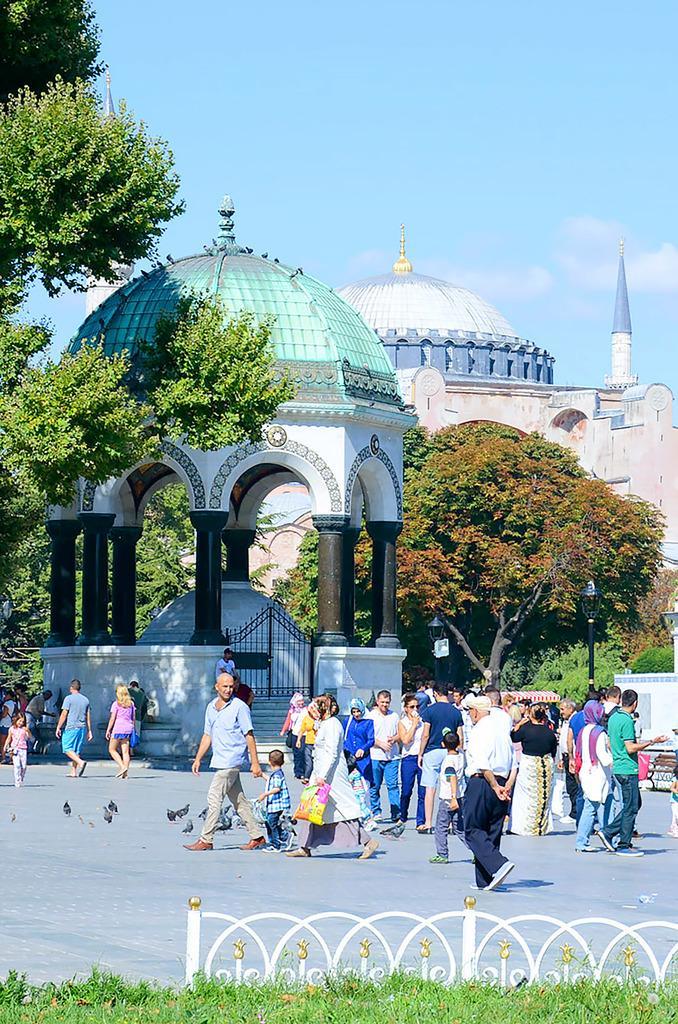Could you give a brief overview of what you see in this image? In this image we can see buildings, trees, iron grills, stairs, birds, plants, poles, street lights, grass, fence and persons on the road. In the background there is sky with clouds. 